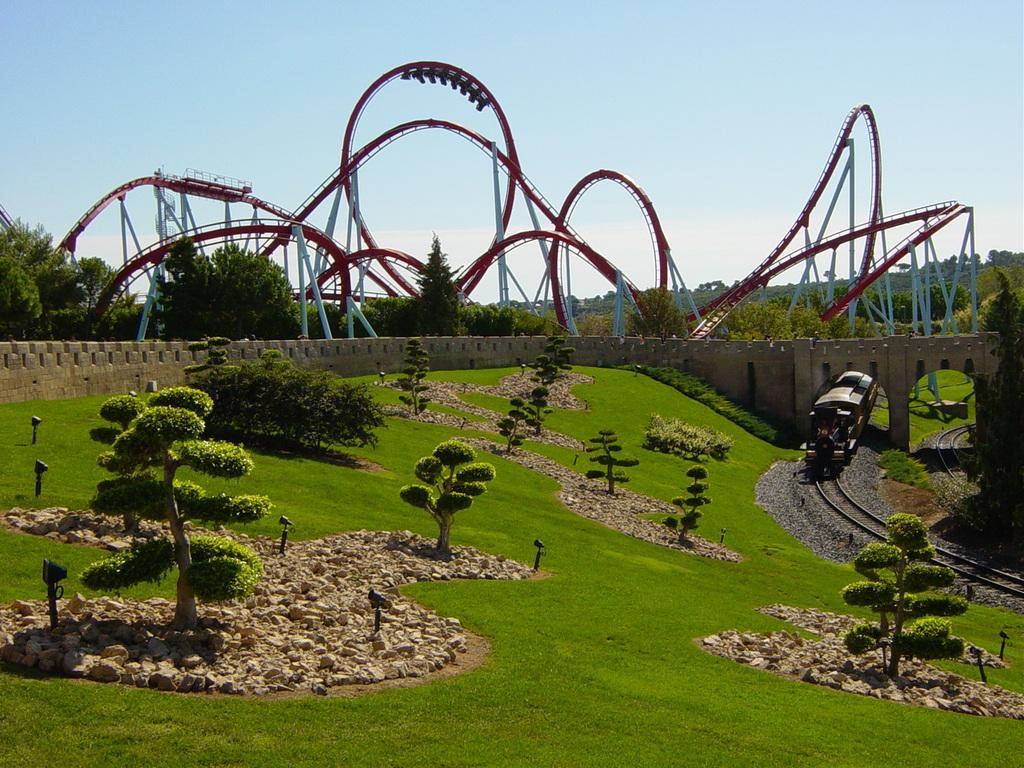In one or two sentences, can you explain what this image depicts? In the center of the image we can see the fun rides. In the background of the image we can see the trees, wall, bridge, grass, plants, train, lights, railway tracks, stones. At the top of the image we can see the sky. At the bottom of the image we can see the ground. 